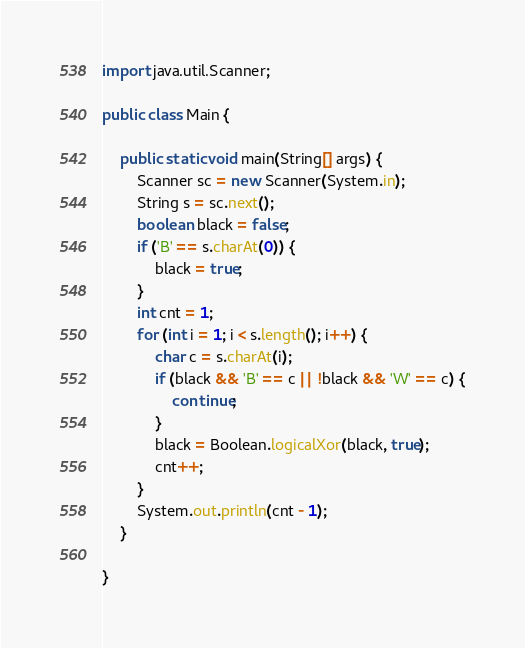<code> <loc_0><loc_0><loc_500><loc_500><_Java_>import java.util.Scanner;

public class Main {

    public static void main(String[] args) {
        Scanner sc = new Scanner(System.in);
        String s = sc.next();
        boolean black = false;
        if ('B' == s.charAt(0)) {
            black = true;
        }
        int cnt = 1;
        for (int i = 1; i < s.length(); i++) {
            char c = s.charAt(i);
            if (black && 'B' == c || !black && 'W' == c) {
                continue;
            }
            black = Boolean.logicalXor(black, true);
            cnt++;
        }
        System.out.println(cnt - 1);
    }

}
</code> 